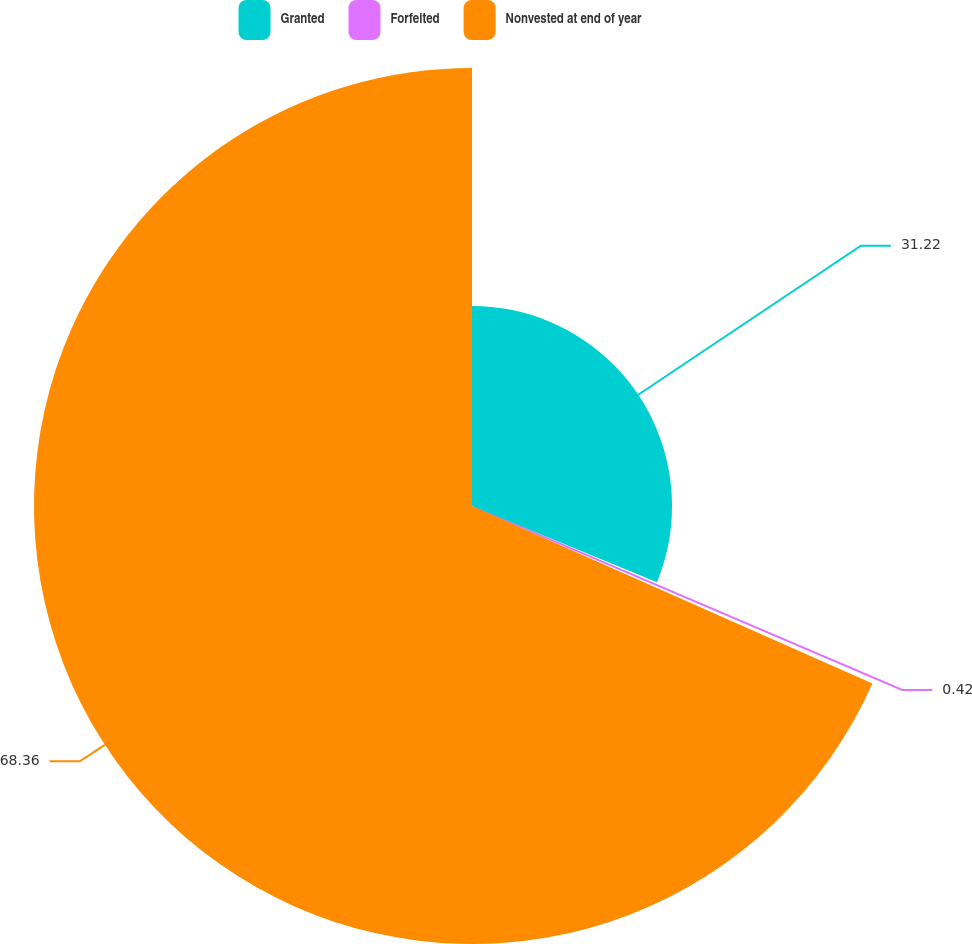Convert chart. <chart><loc_0><loc_0><loc_500><loc_500><pie_chart><fcel>Granted<fcel>Forfeited<fcel>Nonvested at end of year<nl><fcel>31.22%<fcel>0.42%<fcel>68.36%<nl></chart> 